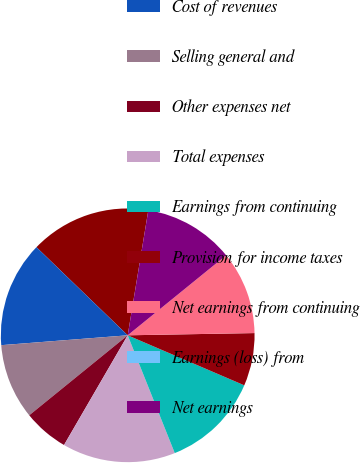Convert chart. <chart><loc_0><loc_0><loc_500><loc_500><pie_chart><fcel>Revenues<fcel>Cost of revenues<fcel>Selling general and<fcel>Other expenses net<fcel>Total expenses<fcel>Earnings from continuing<fcel>Provision for income taxes<fcel>Net earnings from continuing<fcel>Earnings (loss) from<fcel>Net earnings<nl><fcel>15.38%<fcel>13.46%<fcel>9.62%<fcel>5.77%<fcel>14.42%<fcel>12.5%<fcel>6.73%<fcel>10.58%<fcel>0.0%<fcel>11.54%<nl></chart> 